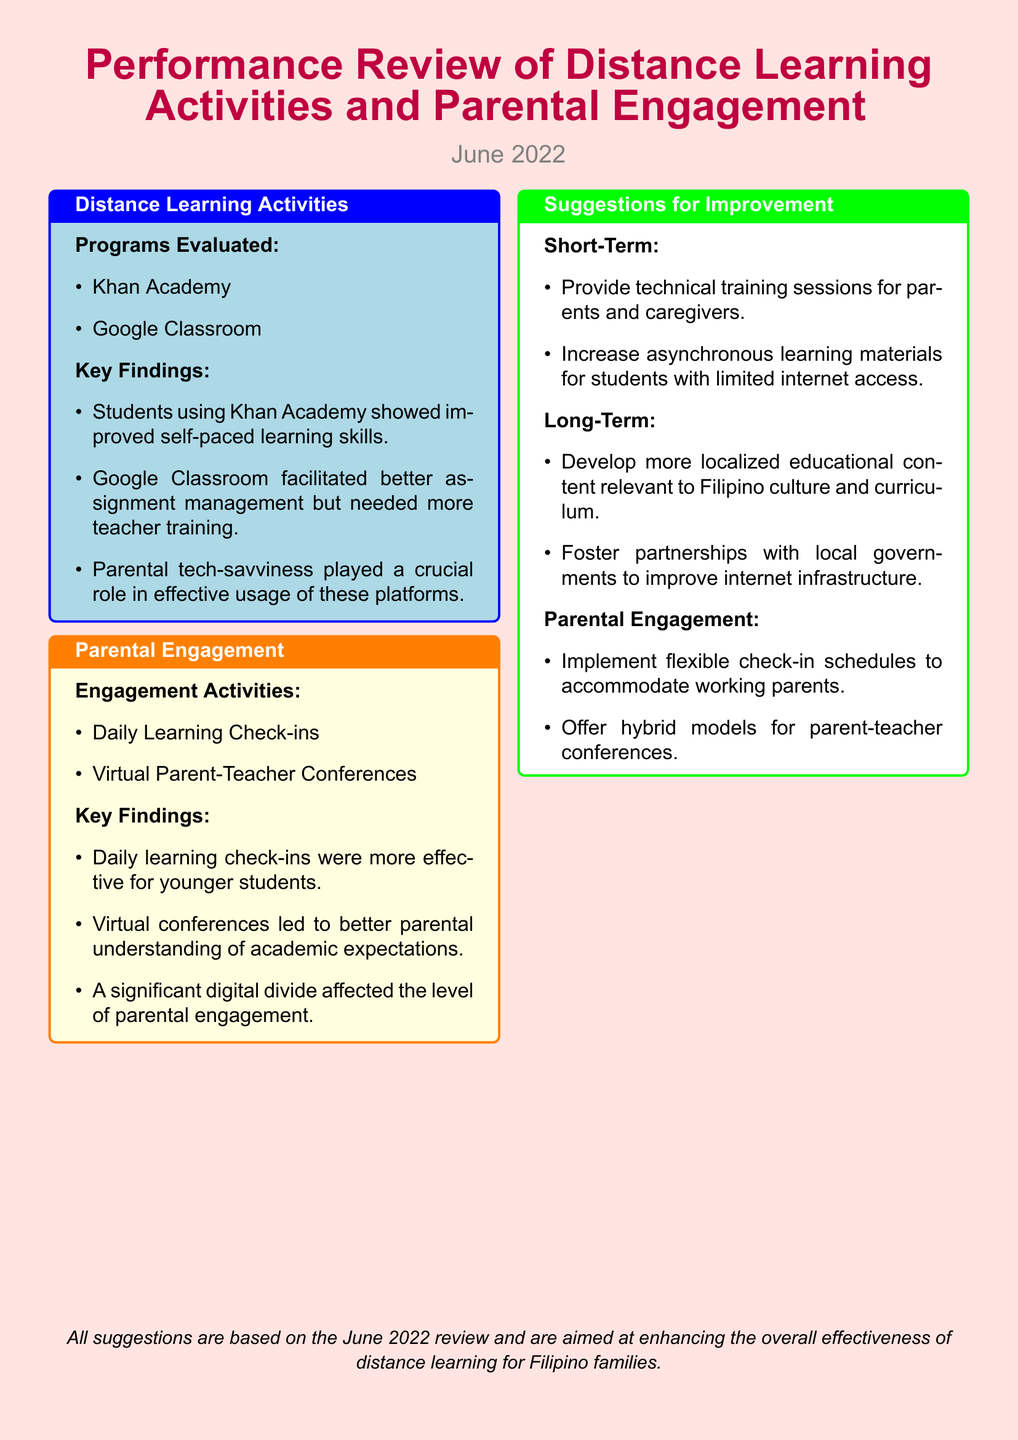What programs were evaluated for distance learning activities? The document lists the programs evaluated for distance learning activities, which are Khan Academy and Google Classroom.
Answer: Khan Academy, Google Classroom What was a key finding regarding Google Classroom? The document states that while Google Classroom facilitated better assignment management, it needed more teacher training.
Answer: Needed more teacher training What types of engagement activities were mentioned? The engagement activities mentioned in the document include Daily Learning Check-ins and Virtual Parent-Teacher Conferences.
Answer: Daily Learning Check-ins, Virtual Parent-Teacher Conferences Which type of students found daily learning check-ins more effective? The document specifies that daily learning check-ins were more effective for younger students.
Answer: Younger students What is one short-term suggestion for improvement? The document lists several suggestions for improvement, one of which is to provide technical training sessions for parents and caregivers.
Answer: Provide technical training sessions for parents and caregivers What long-term suggestion involves local culture? The document suggests developing more localized educational content relevant to Filipino culture and curriculum as a long-term improvement.
Answer: Localized educational content relevant to Filipino culture What aspect affected parental engagement, according to the findings? The document highlights that a significant digital divide affected the level of parental engagement.
Answer: Significant digital divide What is suggested for accommodating working parents? The document suggests implementing flexible check-in schedules to accommodate working parents.
Answer: Flexible check-in schedules 